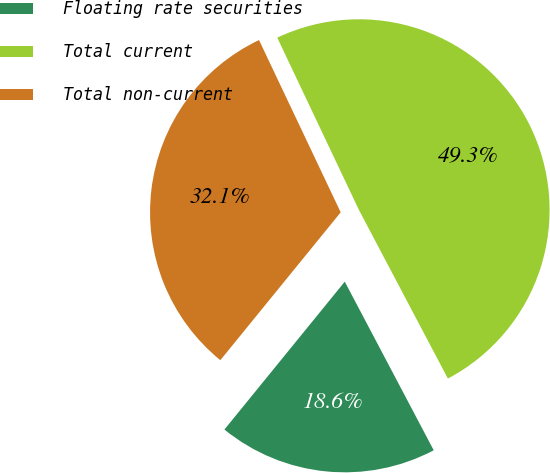<chart> <loc_0><loc_0><loc_500><loc_500><pie_chart><fcel>Floating rate securities<fcel>Total current<fcel>Total non-current<nl><fcel>18.6%<fcel>49.32%<fcel>32.08%<nl></chart> 